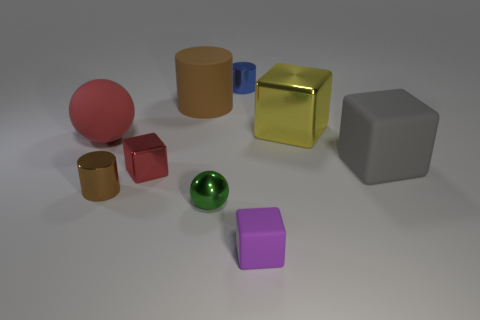Subtract 1 cubes. How many cubes are left? 3 Subtract all blocks. How many objects are left? 5 Add 7 large gray objects. How many large gray objects exist? 8 Subtract 0 gray spheres. How many objects are left? 9 Subtract all tiny brown cylinders. Subtract all big metallic cubes. How many objects are left? 7 Add 4 shiny balls. How many shiny balls are left? 5 